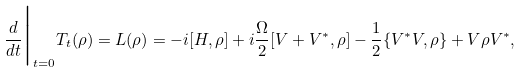Convert formula to latex. <formula><loc_0><loc_0><loc_500><loc_500>\frac { d } { d t } \Big | _ { t = 0 } T _ { t } ( \rho ) = L ( \rho ) = - i [ H , \rho ] + i \frac { \Omega } { 2 } [ V + V ^ { * } , \rho ] - \frac { 1 } { 2 } \{ V ^ { * } V , \rho \} + V \rho V ^ { * } ,</formula> 